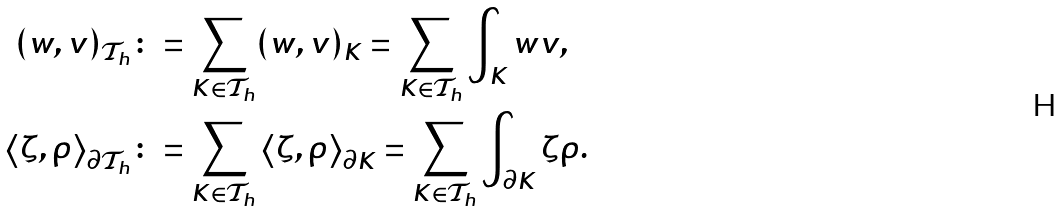<formula> <loc_0><loc_0><loc_500><loc_500>( w , v ) _ { \mathcal { T } _ { h } } & \colon = \sum _ { K \in \mathcal { T } _ { h } } ( w , v ) _ { K } = \sum _ { K \in \mathcal { T } _ { h } } \int _ { K } w v , \\ \left \langle \zeta , \rho \right \rangle _ { \partial \mathcal { T } _ { h } } & \colon = \sum _ { K \in \mathcal { T } _ { h } } \left \langle \zeta , \rho \right \rangle _ { \partial K } = \sum _ { K \in \mathcal { T } _ { h } } \int _ { \partial K } \zeta \rho .</formula> 